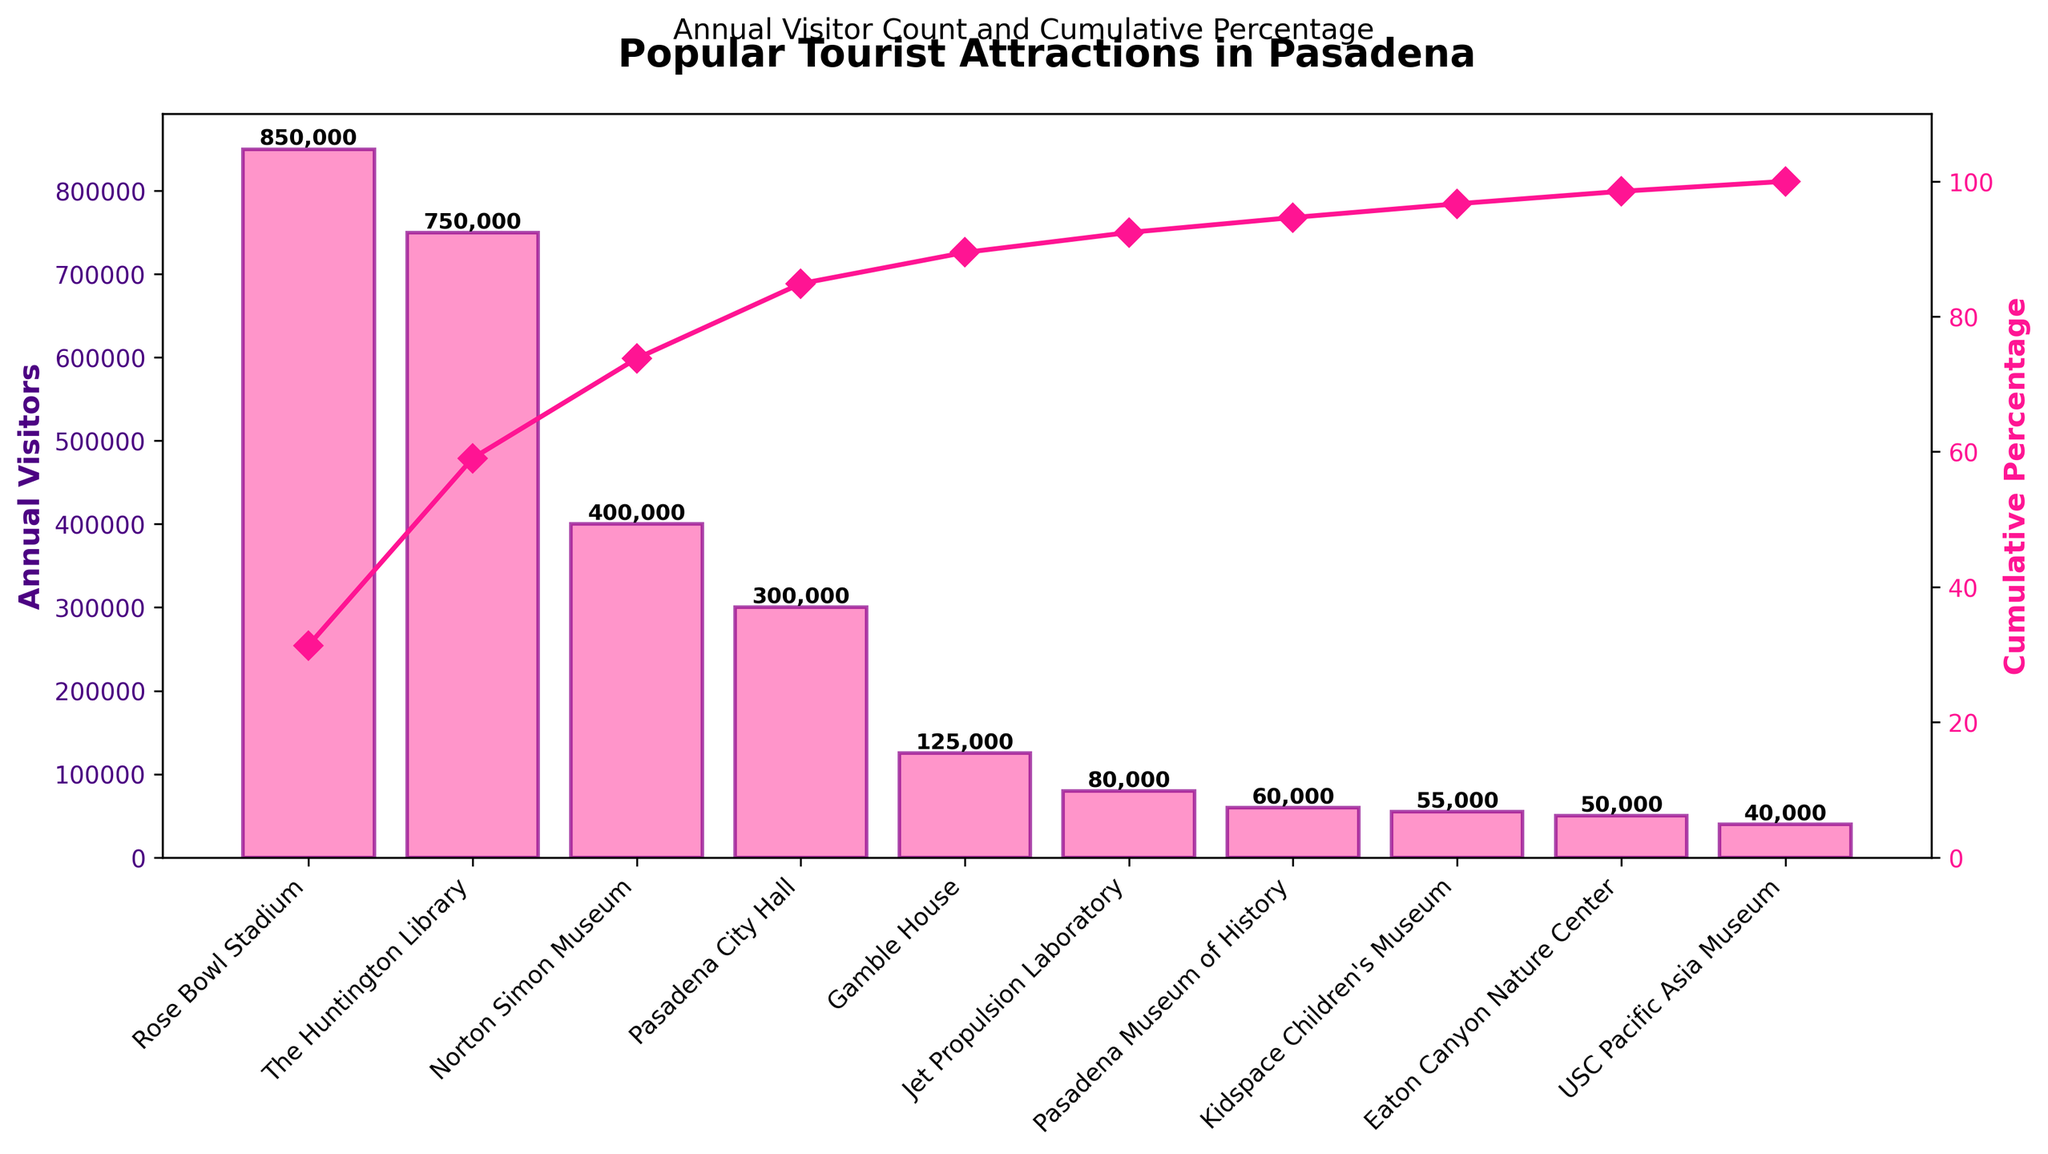What is the title of the figure? The title is usually found at the top center of the figure and provides a brief description of what the figure is about, which in this case is related to tourist attractions in Pasadena.
Answer: Popular Tourist Attractions in Pasadena Which attraction has the highest annual visitors? To find the attraction with the highest annual visitors, look for the tallest bar in the chart, as this represents the highest value.
Answer: Rose Bowl Stadium What is the cumulative percentage for The Huntington Library? You need to locate The Huntington Library on the x-axis and follow the associated cumulative percentage line (often denoted by a line with markers) to the y-axis on the right.
Answer: Approximately 60% How many attractions have fewer than 100,000 annual visitors? Identify and count the bars with heights representing values below 100,000 on the y-axis.
Answer: 5 What is the total number of annual visitors for the top three attractions combined? Look at the heights of the bars for the top three attractions on the x-axis, sum their values: Rose Bowl Stadium (850,000) + The Huntington Library (750,000) + Norton Simon Museum (400,000). The sum is 850,000 + 750,000 + 400,000 = 2,000,000.
Answer: 2,000,000 Compare the annual visitors of Pasadena City Hall and Gamble House. Which one has more? Identify the bars for Pasadena City Hall and Gamble House, and compare their heights. Pasadena City Hall has 300,000 visitors, while Gamble House has 125,000. Pasadena City Hall has more visitors.
Answer: Pasadena City Hall What percentage of total visitors does the Pasadena Museum of History contribute? Locate the annual visitors for Pasadena Museum of History (60,000) and divide by the total visitors (sum of all bars), then multiply by 100 to get the percentage. Total visitors are: 850,000 + 750,000 + 400,000 + 300,000 + 125,000 + 80,000 + 60,000 + 55,000 + 50,000 + 40,000 = 2,710,000. Therefore, 60,000 / 2,710,000 * 100 ≈ 2.21%.
Answer: Approximately 2.21% How does the cumulative percentage change between Jet Propulsion Laboratory and Pasadena Museum of History? Find the cumulative percentage for each attraction and calculate the difference. Jet Propulsion Laboratory has around 90%, and Pasadena Museum of History has around 97%. The change is 97% - 90% = 7%.
Answer: 7% Which is the least visited attraction and how many annual visitors does it have? Look for the shortest bar on the chart; that will represent the least visited attraction. The USC Pacific Asia Museum is the shortest with 40,000 annual visitors.
Answer: USC Pacific Asia Museum, 40,000 What is the average annual visitors for all listed attractions? Sum the annual visitors for all attractions and divide by the number of attractions: 2,710,000 (total visitors) / 10 (attractions) = 271,000.
Answer: 271,000 